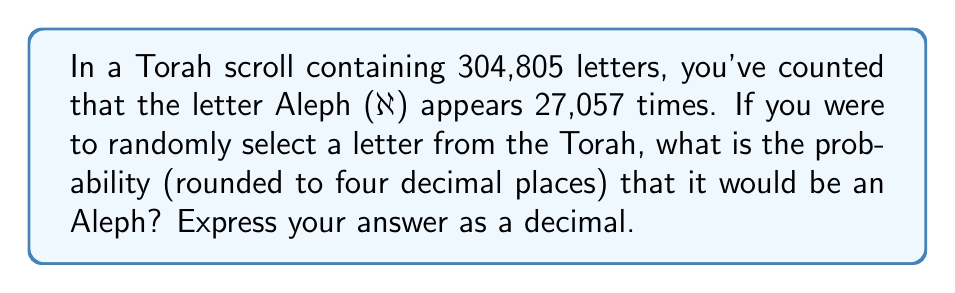What is the answer to this math problem? To solve this problem, we need to use the concept of probability. The probability of an event occurring is calculated by dividing the number of favorable outcomes by the total number of possible outcomes.

In this case:
- The number of favorable outcomes is the number of times Aleph appears: 27,057
- The total number of possible outcomes is the total number of letters in the Torah: 304,805

Let's calculate the probability:

$$ P(\text{Aleph}) = \frac{\text{Number of Alephs}}{\text{Total number of letters}} $$

$$ P(\text{Aleph}) = \frac{27,057}{304,805} $$

Using a calculator to divide these numbers:

$$ P(\text{Aleph}) \approx 0.0887688... $$

Rounding to four decimal places:

$$ P(\text{Aleph}) \approx 0.0888 $$

This means that if you were to randomly select a letter from the Torah, there is approximately an 8.88% chance that it would be an Aleph.
Answer: 0.0888 